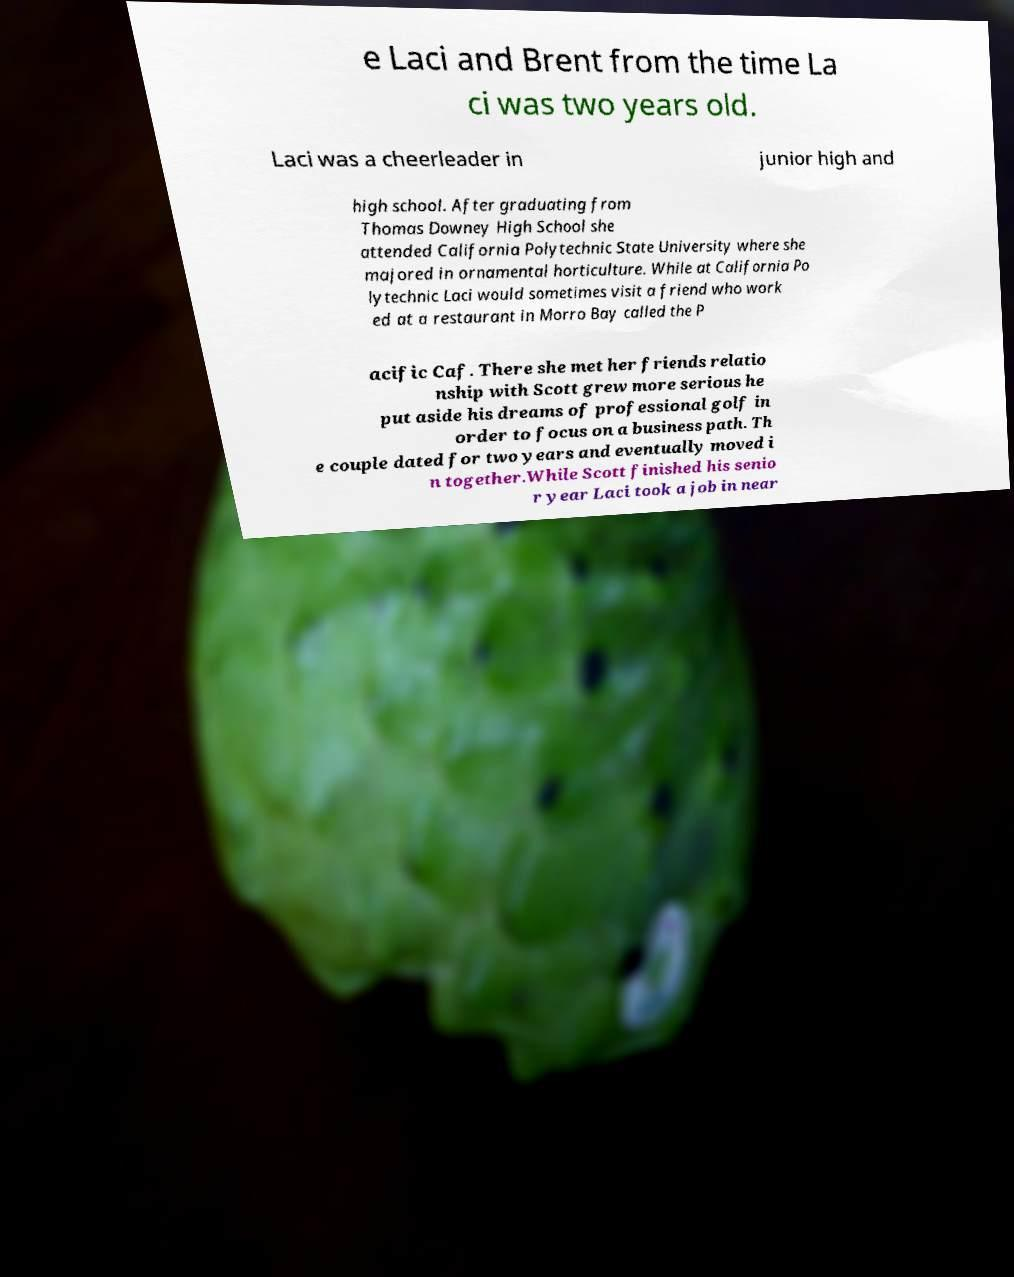Could you assist in decoding the text presented in this image and type it out clearly? e Laci and Brent from the time La ci was two years old. Laci was a cheerleader in junior high and high school. After graduating from Thomas Downey High School she attended California Polytechnic State University where she majored in ornamental horticulture. While at California Po lytechnic Laci would sometimes visit a friend who work ed at a restaurant in Morro Bay called the P acific Caf. There she met her friends relatio nship with Scott grew more serious he put aside his dreams of professional golf in order to focus on a business path. Th e couple dated for two years and eventually moved i n together.While Scott finished his senio r year Laci took a job in near 